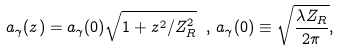Convert formula to latex. <formula><loc_0><loc_0><loc_500><loc_500>a _ { \gamma } ( z ) = a _ { \gamma } ( 0 ) \sqrt { 1 + z ^ { 2 } / Z _ { R } ^ { 2 } } \ , \, a _ { \gamma } ( 0 ) \equiv \sqrt { \frac { \lambda Z _ { R } } { 2 \pi } } ,</formula> 